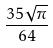<formula> <loc_0><loc_0><loc_500><loc_500>\frac { 3 5 \sqrt { \pi } } { 6 4 }</formula> 